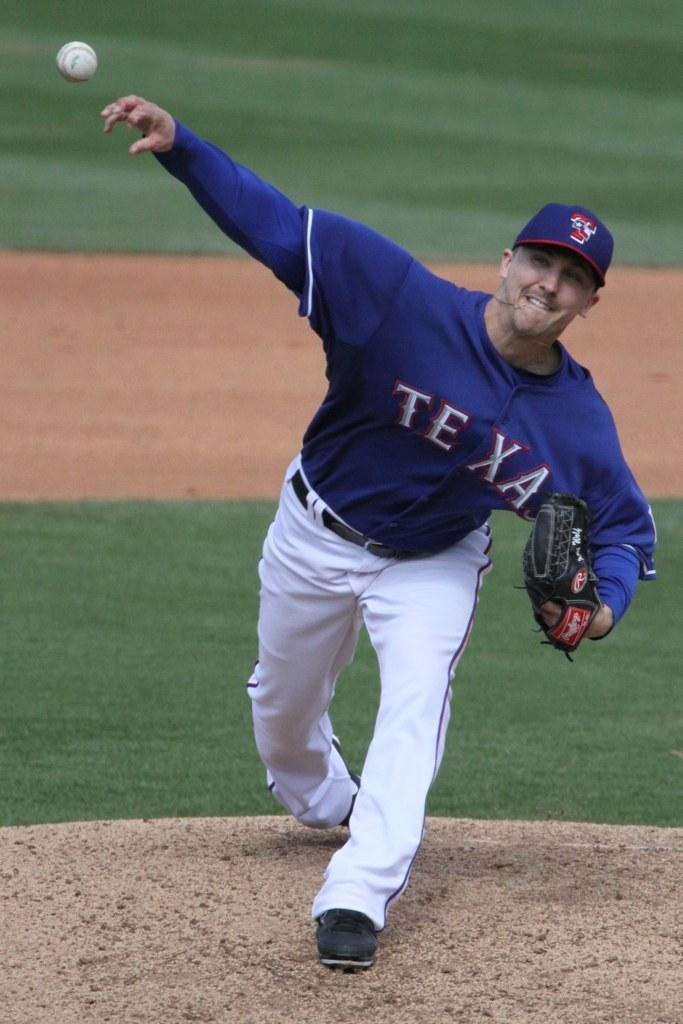<image>
Present a compact description of the photo's key features. The baseball player for the Texas team pitches the ball from the mound. 